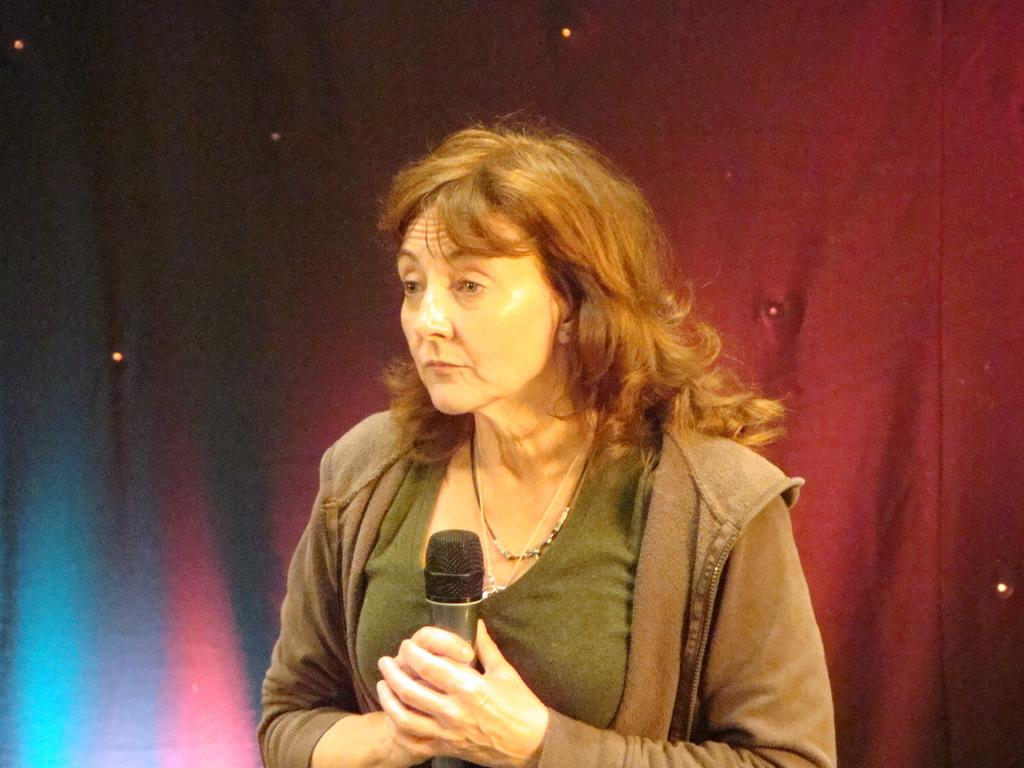What is the main subject of the image? There is a woman in the image. What is the woman doing in the image? The woman is standing in the image. What object is the woman holding in the image? The woman is holding a microphone in the image. What is the color of the microphone? The microphone is black in color. What can be seen in the background of the image? There is a red color curtain in the background of the image. Is the woman holding an umbrella in the image? No, the woman is not holding an umbrella in the image; she is holding a microphone. What type of thing is the woman using to record her voice in the image? There is no indication in the image that the woman is recording her voice, and she is not holding any device that would suggest recording. 